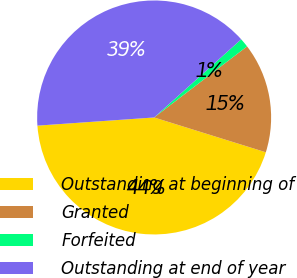Convert chart to OTSL. <chart><loc_0><loc_0><loc_500><loc_500><pie_chart><fcel>Outstanding at beginning of<fcel>Granted<fcel>Forfeited<fcel>Outstanding at end of year<nl><fcel>44.08%<fcel>15.2%<fcel>1.25%<fcel>39.47%<nl></chart> 